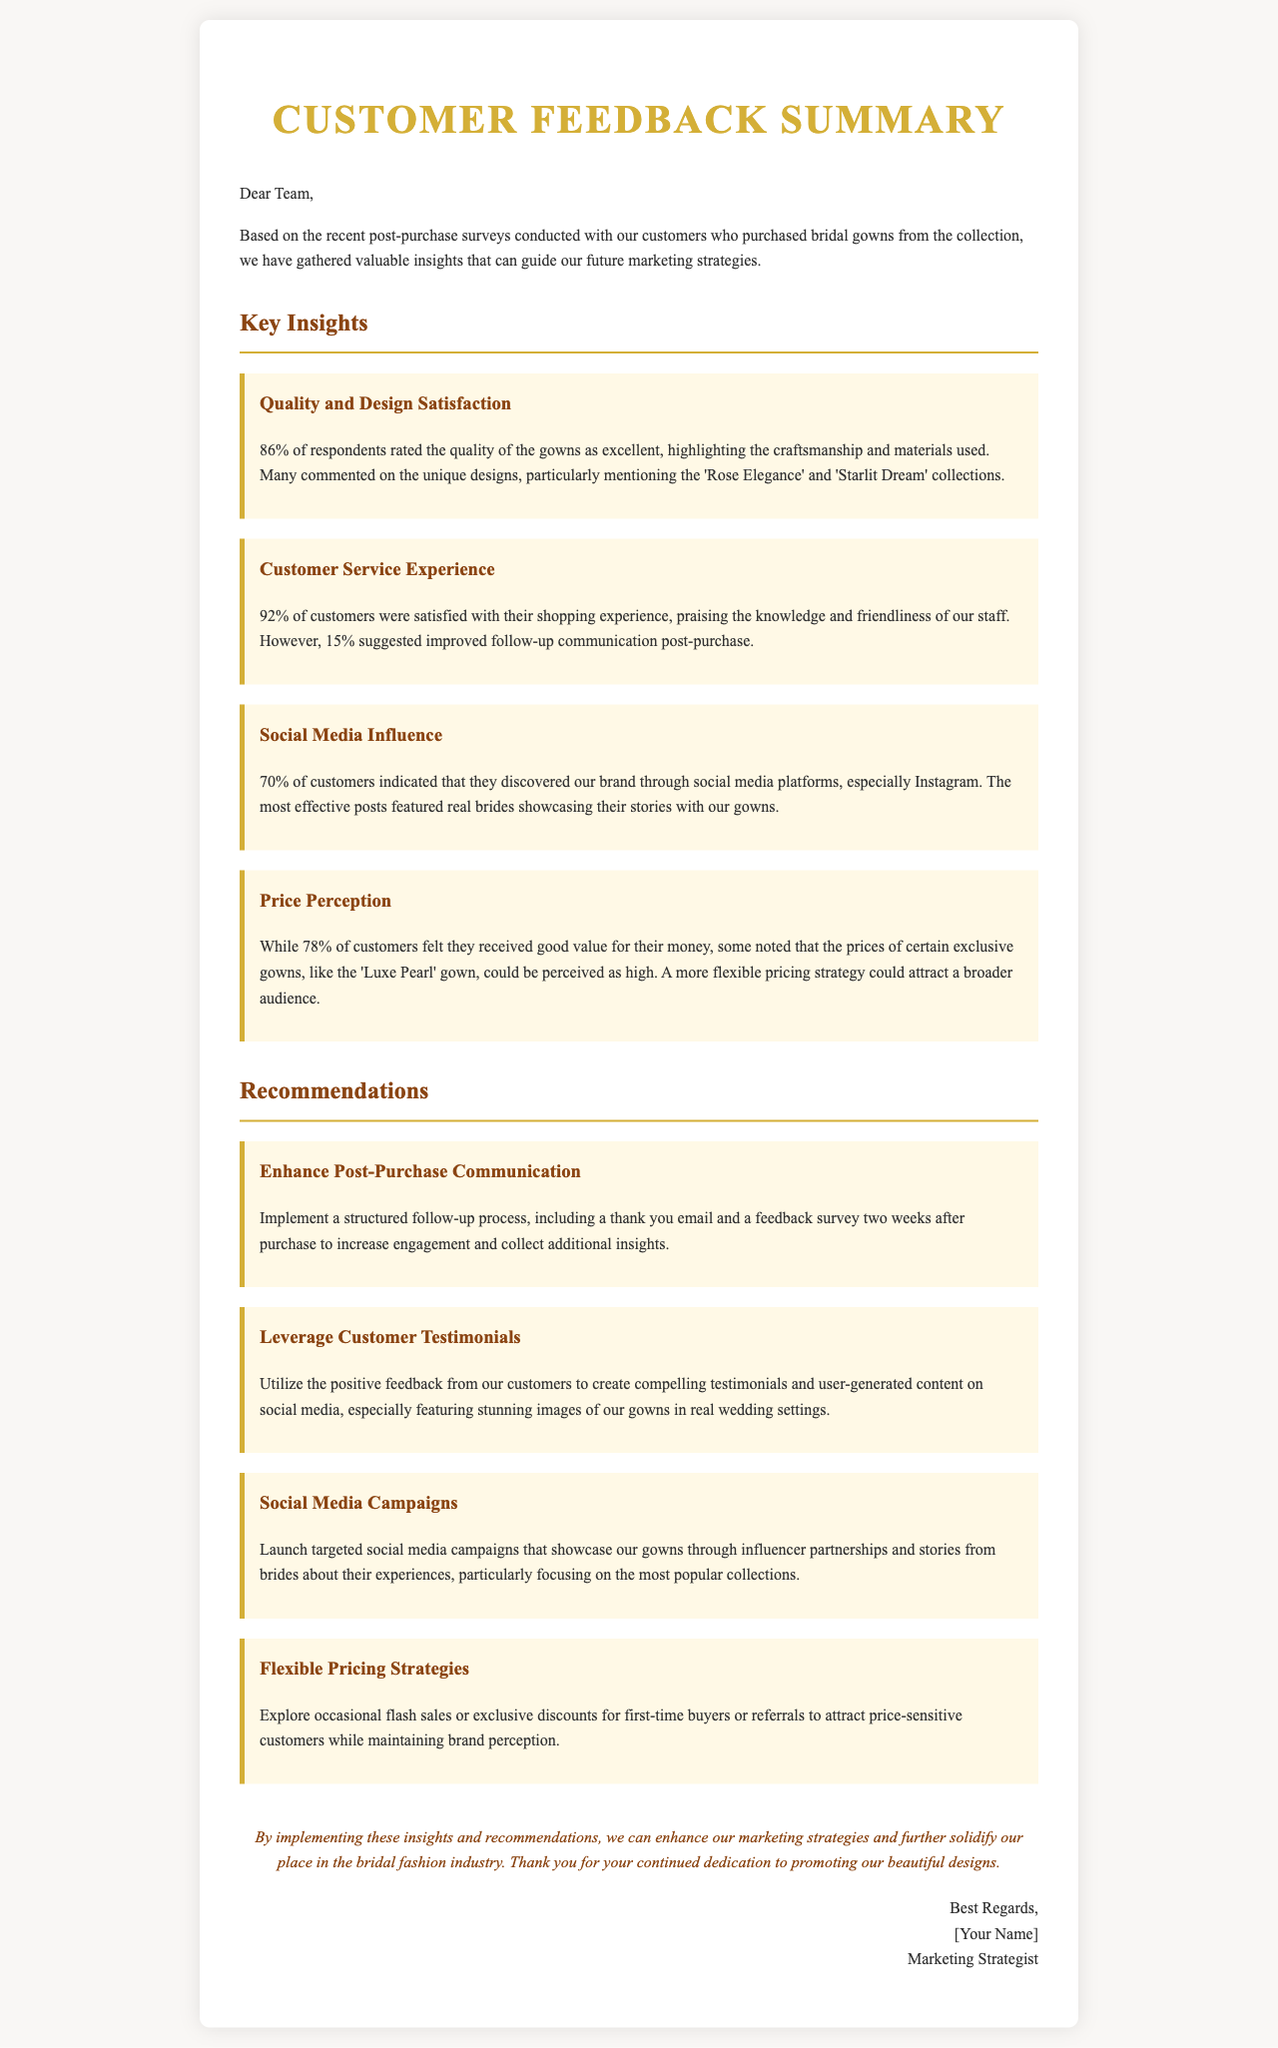What percentage of respondents rated the quality of the gowns as excellent? The percentage of respondents who rated the quality of the gowns as excellent is stated in the document.
Answer: 86% What was the customer satisfaction percentage regarding the shopping experience? The document specifies the satisfaction percentage of customers regarding their shopping experience.
Answer: 92% Which collections received particular mention for their unique designs? The document highlights specific collections mentioned by customers for their unique designs.
Answer: 'Rose Elegance' and 'Starlit Dream' What percentage of customers discovered the brand through social media? The document provides the percentage of customers who discovered the brand via social media platforms.
Answer: 70% What feedback was suggested for post-purchase communication? The document details a suggestion made by customers regarding post-purchase communication.
Answer: Improved follow-up communication What type of campaigns does the document recommend focusing on for social media? The document recommends a specific type of campaign to focus on for social media marketing.
Answer: Targeted social media campaigns What is one of the flexible pricing strategies mentioned? The document lists a flexible pricing strategy to attract price-sensitive customers.
Answer: Occasional flash sales What does the conclusion suggest about implementing insights and recommendations? The conclusion provides a statement on what can be achieved by implementing the insights and recommendations discussed in the document.
Answer: Enhance marketing strategies Who is the author of the letter? The author's name appears at the end of the letter, as the person responsible for the message.
Answer: [Your Name] 